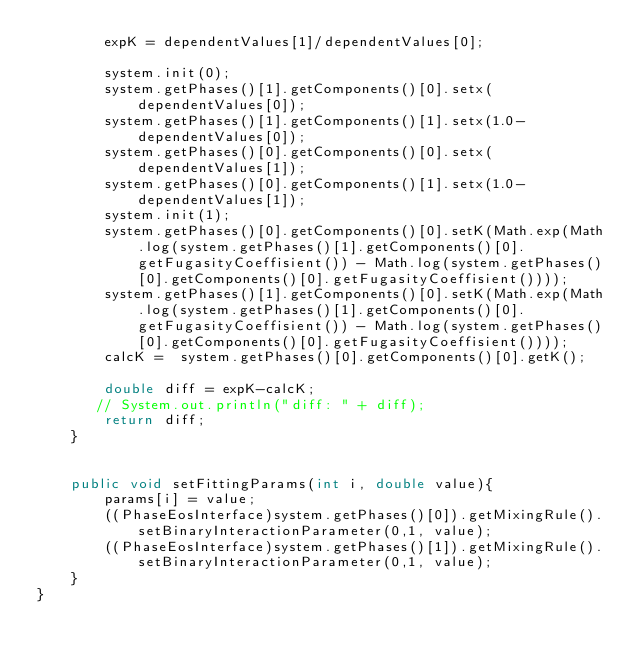Convert code to text. <code><loc_0><loc_0><loc_500><loc_500><_Java_>        expK = dependentValues[1]/dependentValues[0];
        
        system.init(0);
        system.getPhases()[1].getComponents()[0].setx(dependentValues[0]);
        system.getPhases()[1].getComponents()[1].setx(1.0-dependentValues[0]);
        system.getPhases()[0].getComponents()[0].setx(dependentValues[1]);
        system.getPhases()[0].getComponents()[1].setx(1.0-dependentValues[1]);
        system.init(1);
        system.getPhases()[0].getComponents()[0].setK(Math.exp(Math.log(system.getPhases()[1].getComponents()[0].getFugasityCoeffisient()) - Math.log(system.getPhases()[0].getComponents()[0].getFugasityCoeffisient())));
        system.getPhases()[1].getComponents()[0].setK(Math.exp(Math.log(system.getPhases()[1].getComponents()[0].getFugasityCoeffisient()) - Math.log(system.getPhases()[0].getComponents()[0].getFugasityCoeffisient())));
        calcK =  system.getPhases()[0].getComponents()[0].getK();
        
        double diff = expK-calcK;
       // System.out.println("diff: " + diff);
        return diff;
    }
    
    
    public void setFittingParams(int i, double value){
        params[i] = value;
        ((PhaseEosInterface)system.getPhases()[0]).getMixingRule().setBinaryInteractionParameter(0,1, value);
        ((PhaseEosInterface)system.getPhases()[1]).getMixingRule().setBinaryInteractionParameter(0,1, value);
    }
}</code> 